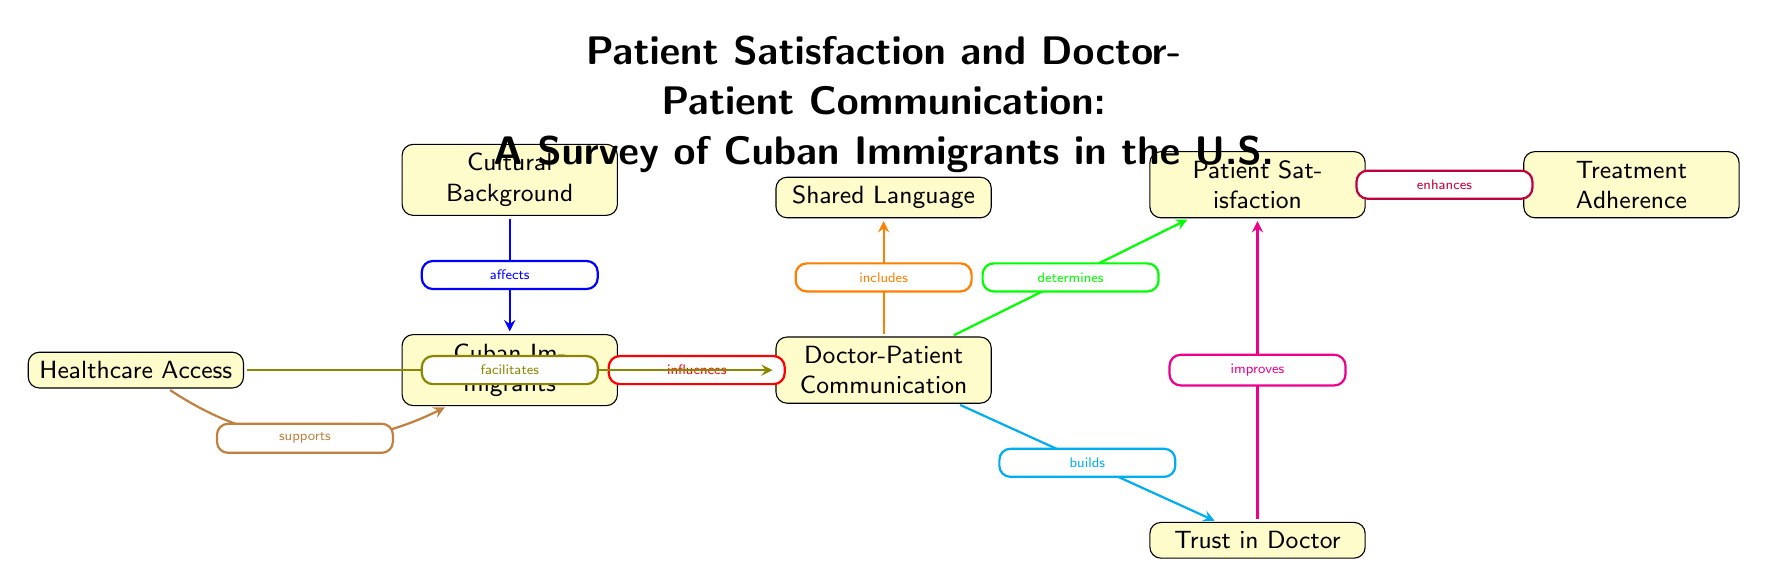What's the primary node in the diagram? The primary node at the top of the diagram is "Cultural Background," which serves as the foundation for the flow of relationships illustrated in the diagram.
Answer: Cultural Background How many nodes are present in the diagram? There are a total of 8 nodes in the diagram, each representing a different aspect of the relationships involving Cuban immigrants' healthcare experiences.
Answer: 8 What relationship exists between "Doctor-Patient Communication" and "Patient Satisfaction"? The diagram indicates that "Doctor-Patient Communication" determines "Patient Satisfaction," highlighting the significance of communication in patient experiences.
Answer: determines What does "Shared Language" relate to in the diagram? The "Shared Language" node is a component that includes the "Doctor-Patient Communication," indicating that having a common language is an aspect of effective communication between doctors and patients.
Answer: includes What effect does "Trust in Doctor" have on "Patient Satisfaction"? According to the diagram, "Trust in Doctor" improves "Patient Satisfaction," suggesting that a strong trusting relationship contributes positively to patient experiences.
Answer: improves If "Healthcare Access" is facilitated, which node does it connect to? "Healthcare Access" connects to "Doctor-Patient Communication," as indicated by the arrow, showing that access to healthcare can enhance communication between doctors and patients.
Answer: Doctor-Patient Communication What is the role of "Treatment Adherence" in the context of the diagram? "Treatment Adherence" is enhanced by "Patient Satisfaction," implying that when patients are satisfied with their care, they are likely to adhere better to treatment plans.
Answer: enhances Which aspect does "Cultural Background" directly affect? "Cultural Background" directly affects "Cuban Immigrants," establishing a direct connection that influences the experiences of these individuals in healthcare contexts.
Answer: Cuban Immigrants What color indicates the relationship of "Doctor-Patient Communication" to "Trust in Doctor"? The relationship between "Doctor-Patient Communication" and "Trust in Doctor" is colored cyan, representing its significance in the diagram.
Answer: cyan 